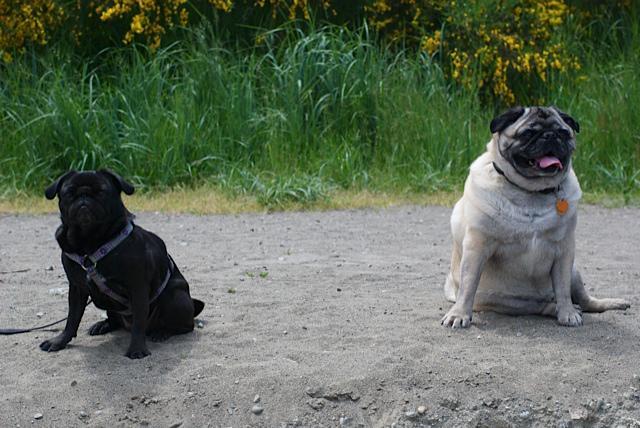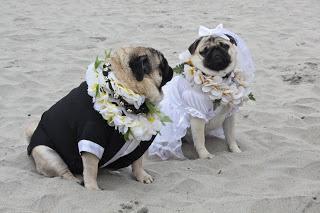The first image is the image on the left, the second image is the image on the right. Examine the images to the left and right. Is the description "An animal wearing clothing is present." accurate? Answer yes or no. Yes. The first image is the image on the left, the second image is the image on the right. Examine the images to the left and right. Is the description "Four dogs are in sand." accurate? Answer yes or no. Yes. 